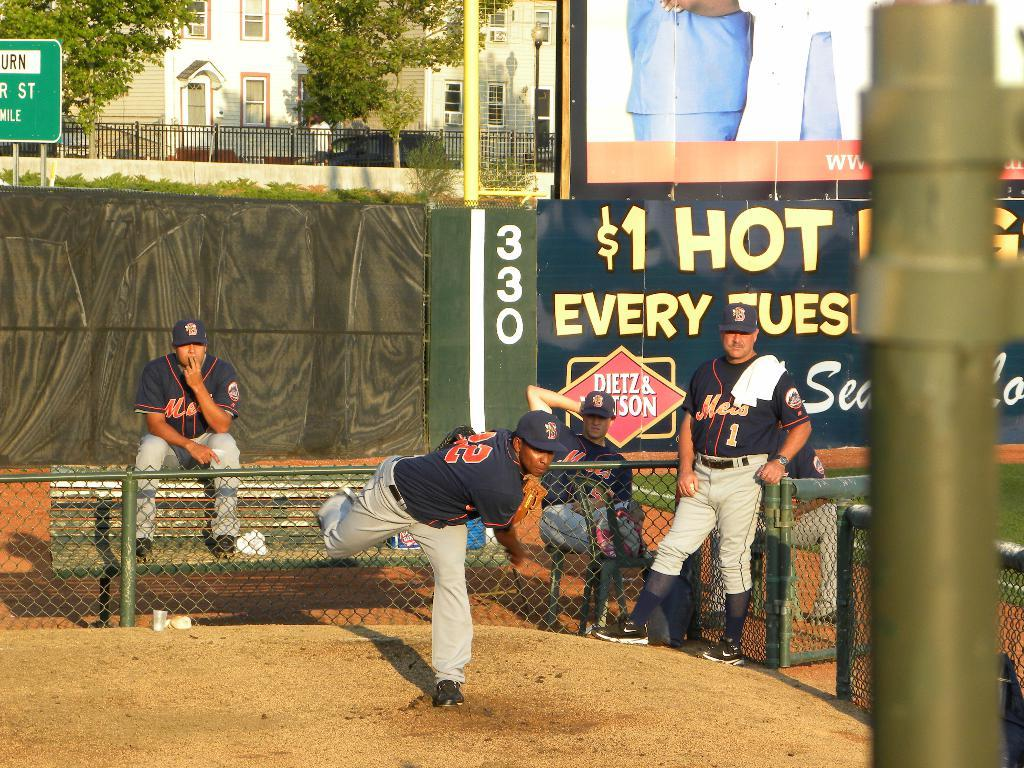<image>
Present a compact description of the photo's key features. A baseball team is practicing in front of a sign that says $1 Hot Every Tuesday. 